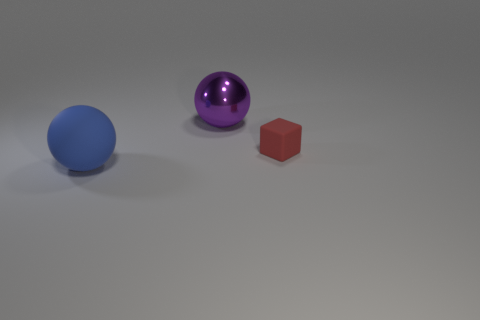There is a object that is left of the small block and to the right of the large blue sphere; what is its shape?
Ensure brevity in your answer.  Sphere. How many cyan things are large shiny balls or cubes?
Provide a short and direct response. 0. Is the size of the thing that is on the left side of the purple shiny ball the same as the thing behind the small rubber object?
Your answer should be compact. Yes. What number of objects are small cubes or large red matte objects?
Offer a terse response. 1. Are there any big blue objects of the same shape as the red matte object?
Provide a succinct answer. No. Are there fewer rubber blocks than tiny purple matte cylinders?
Offer a very short reply. No. Does the blue matte thing have the same shape as the metallic object?
Provide a succinct answer. Yes. How many objects are either big yellow metallic cubes or big spheres that are in front of the purple thing?
Offer a terse response. 1. What number of tiny brown metal balls are there?
Your answer should be very brief. 0. Is there a blue matte object of the same size as the blue sphere?
Your response must be concise. No. 